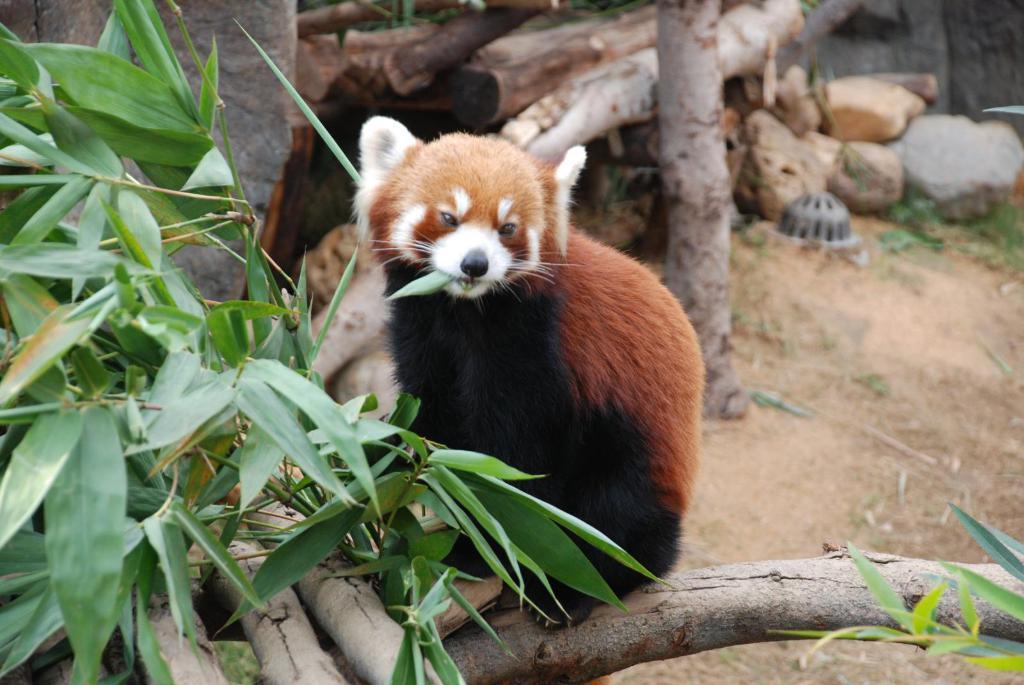How would you summarize this image in a sentence or two? In this image in the center there is one animal, and on the left side there are some leaves and some trees. In the background there are some wooden poles, rocks and some trees. At the bottom there is sand and grass. 